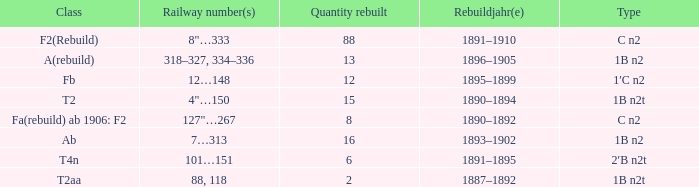What was the Rebuildjahr(e) for the T2AA class? 1887–1892. 